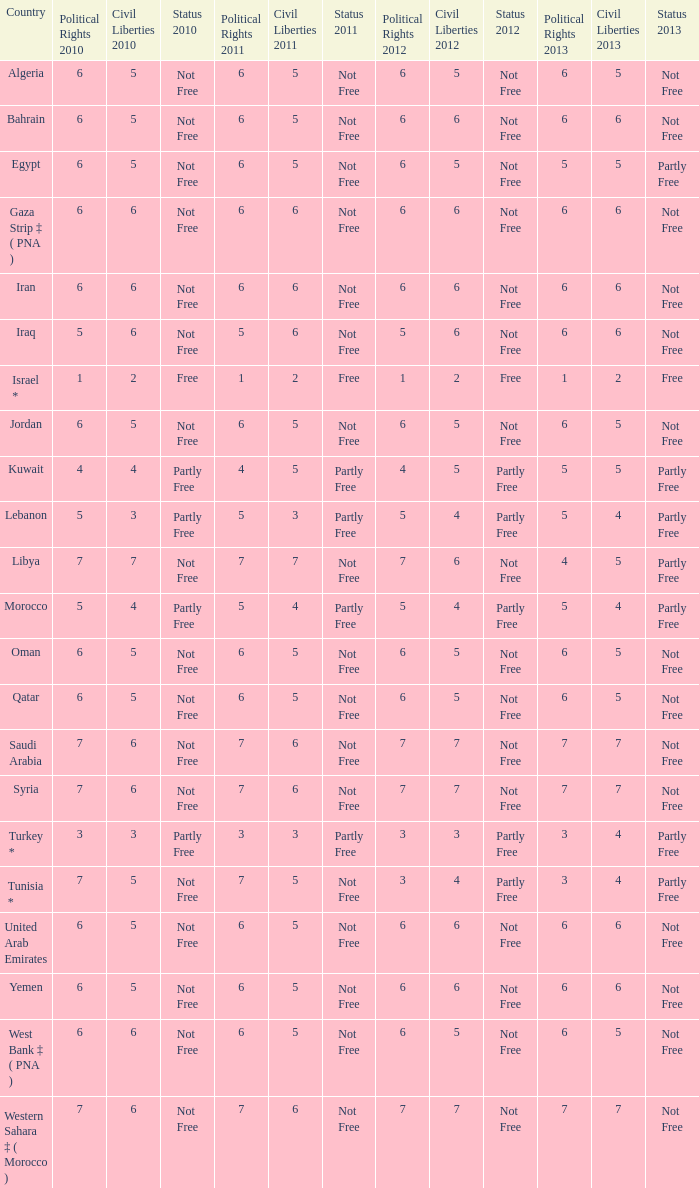What is the total number of civil liberties 2011 values having 2010 political rights values under 3 and 2011 political rights values under 1? 0.0. 